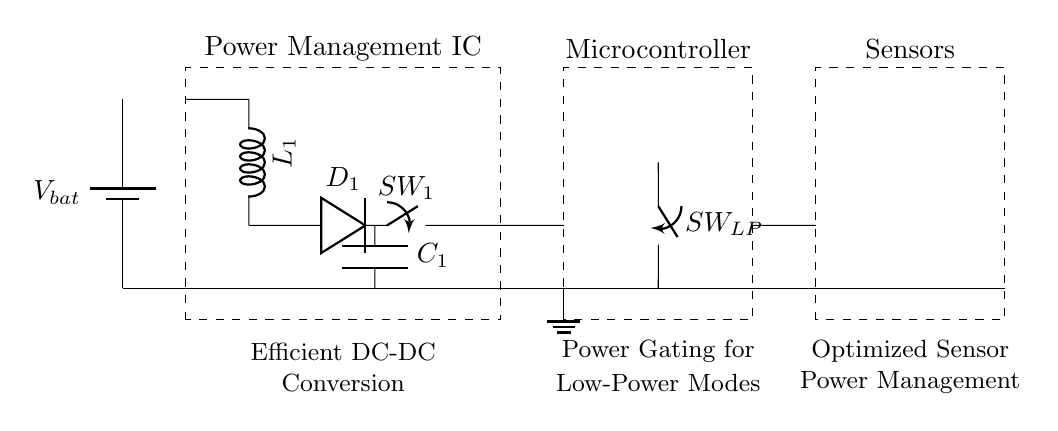What is the main role of the Power Management IC? The Power Management IC is responsible for controlling the power distribution in the circuit to optimize battery life, ensuring efficient operation of components.
Answer: controlling power distribution What is the function of the buck-boost converter illustrated in the circuit? The buck-boost converter regulates the voltage from the battery, allowing for efficient energy management and maintaining stable voltage levels necessary for the circuit's operation.
Answer: regulates voltage How many switches are present in the circuit? There are two switches: one is a load switch and the other is a low-power mode switch, allowing control over power distribution and modes of operation.
Answer: two switches What do the components labeled with C represent? The component labeled with C refers to a capacitor in the circuit, which is used for filtering and stabilizing voltage levels for better performance.
Answer: capacitor What is the main advantage of implementing a low-power mode switch? The low-power mode switch offers enhanced battery life by reducing power consumption when the device is inactive, allowing for prolonged usage of the fitness tracker.
Answer: enhanced battery life What type of sensors could be integrated into this circuit? The sensors can include heart rate monitors, accelerometers, or GPS modules, which contribute to collecting fitness data while optimizing their power consumption through effective management.
Answer: fitness data sensors 